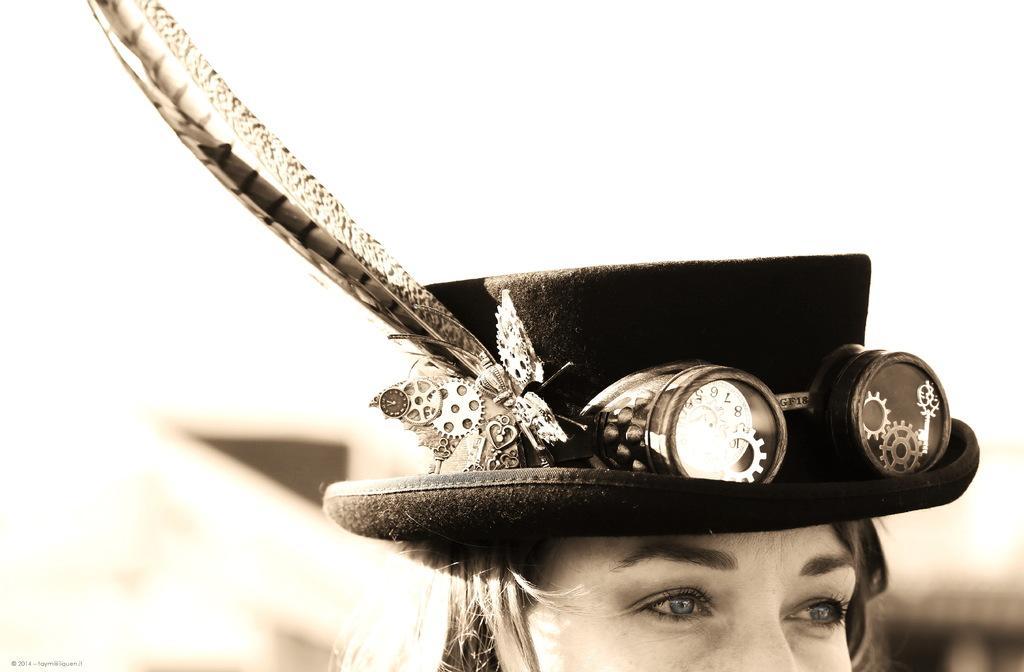Please provide a concise description of this image. In this image there is a girl wearing a hat on her head. The background is blurred. 